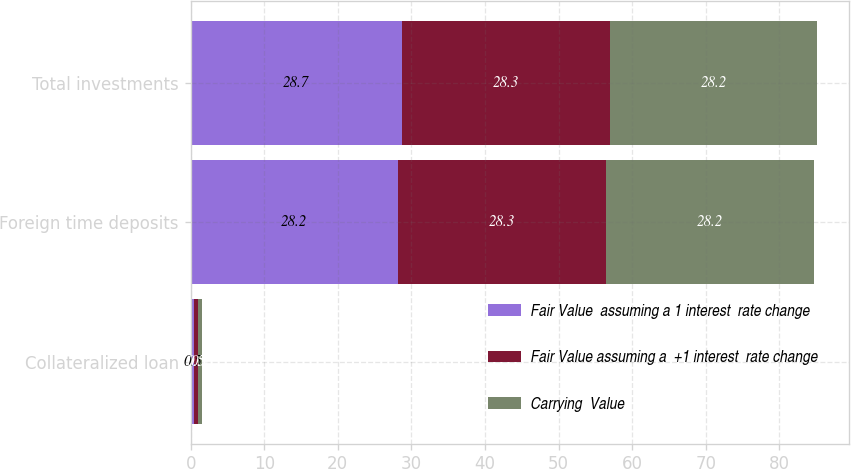Convert chart to OTSL. <chart><loc_0><loc_0><loc_500><loc_500><stacked_bar_chart><ecel><fcel>Collateralized loan<fcel>Foreign time deposits<fcel>Total investments<nl><fcel>Fair Value  assuming a 1 interest  rate change<fcel>0.5<fcel>28.2<fcel>28.7<nl><fcel>Fair Value assuming a  +1 interest  rate change<fcel>0.5<fcel>28.3<fcel>28.3<nl><fcel>Carrying  Value<fcel>0.5<fcel>28.2<fcel>28.2<nl></chart> 